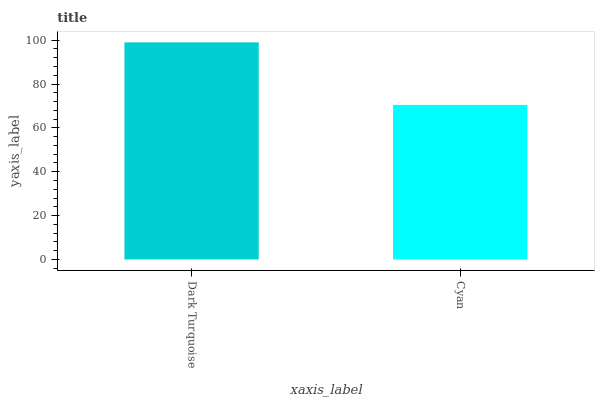Is Cyan the minimum?
Answer yes or no. Yes. Is Dark Turquoise the maximum?
Answer yes or no. Yes. Is Cyan the maximum?
Answer yes or no. No. Is Dark Turquoise greater than Cyan?
Answer yes or no. Yes. Is Cyan less than Dark Turquoise?
Answer yes or no. Yes. Is Cyan greater than Dark Turquoise?
Answer yes or no. No. Is Dark Turquoise less than Cyan?
Answer yes or no. No. Is Dark Turquoise the high median?
Answer yes or no. Yes. Is Cyan the low median?
Answer yes or no. Yes. Is Cyan the high median?
Answer yes or no. No. Is Dark Turquoise the low median?
Answer yes or no. No. 